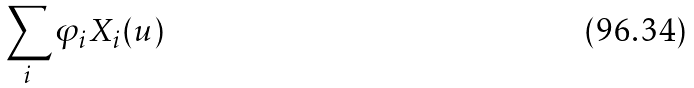<formula> <loc_0><loc_0><loc_500><loc_500>\sum _ { i } \varphi _ { i } X _ { i } ( u )</formula> 